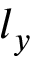<formula> <loc_0><loc_0><loc_500><loc_500>l _ { y }</formula> 